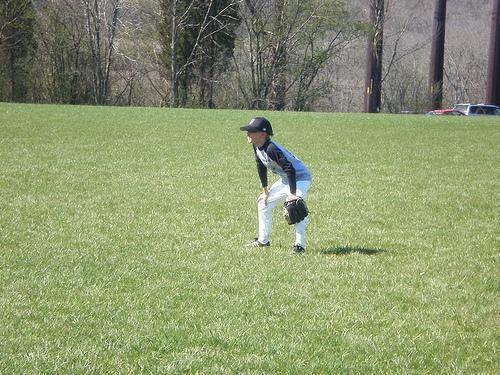What aspect of the game is being shown here?
Pick the correct solution from the four options below to address the question.
Options: Cheering, fielding, hitting, umpiring. Fielding. 